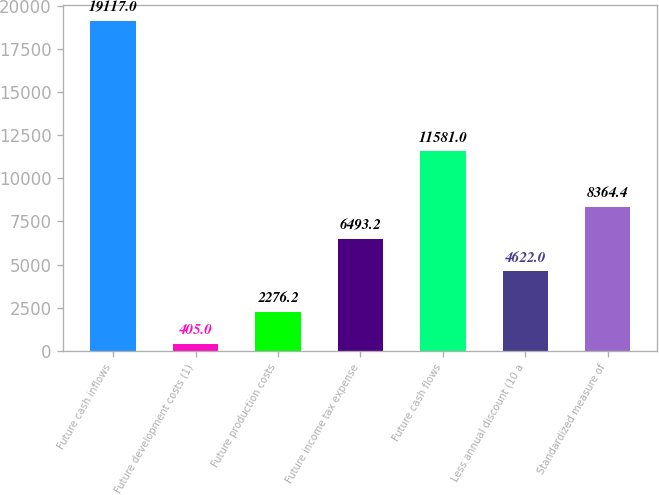<chart> <loc_0><loc_0><loc_500><loc_500><bar_chart><fcel>Future cash inflows<fcel>Future development costs (1)<fcel>Future production costs<fcel>Future income tax expense<fcel>Future cash flows<fcel>Less annual discount (10 a<fcel>Standardized measure of<nl><fcel>19117<fcel>405<fcel>2276.2<fcel>6493.2<fcel>11581<fcel>4622<fcel>8364.4<nl></chart> 